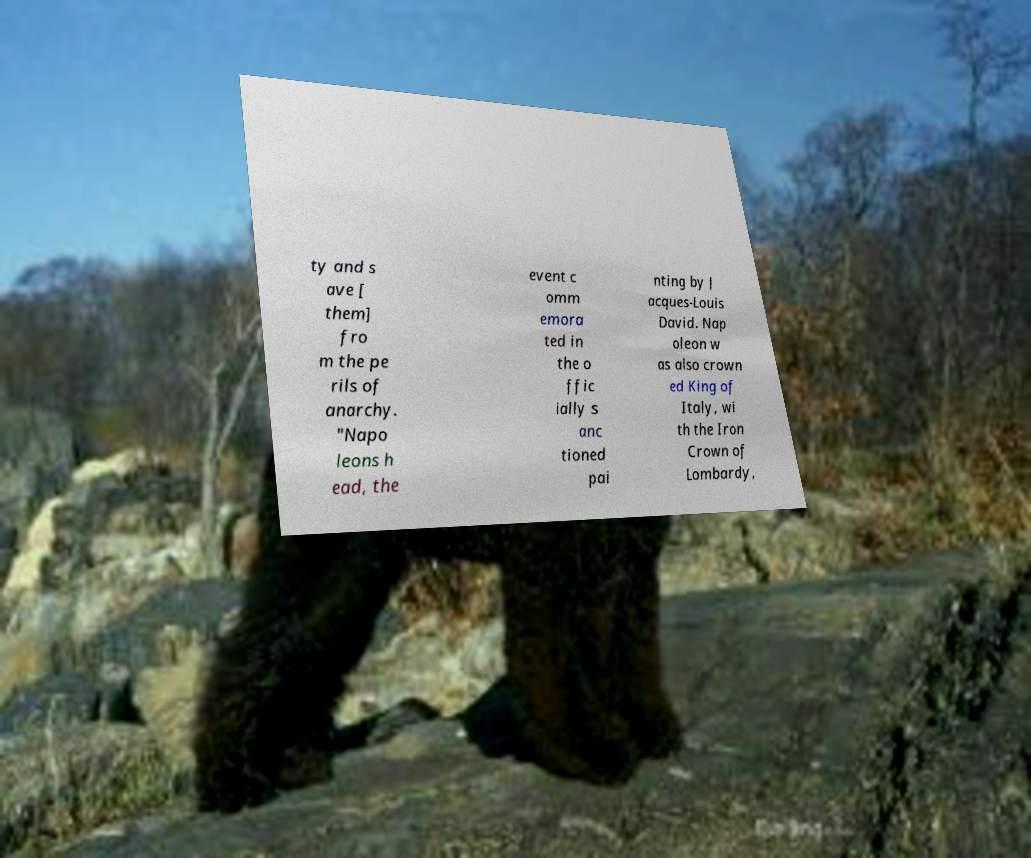Please read and relay the text visible in this image. What does it say? ty and s ave [ them] fro m the pe rils of anarchy. "Napo leons h ead, the event c omm emora ted in the o ffic ially s anc tioned pai nting by J acques-Louis David. Nap oleon w as also crown ed King of Italy, wi th the Iron Crown of Lombardy, 